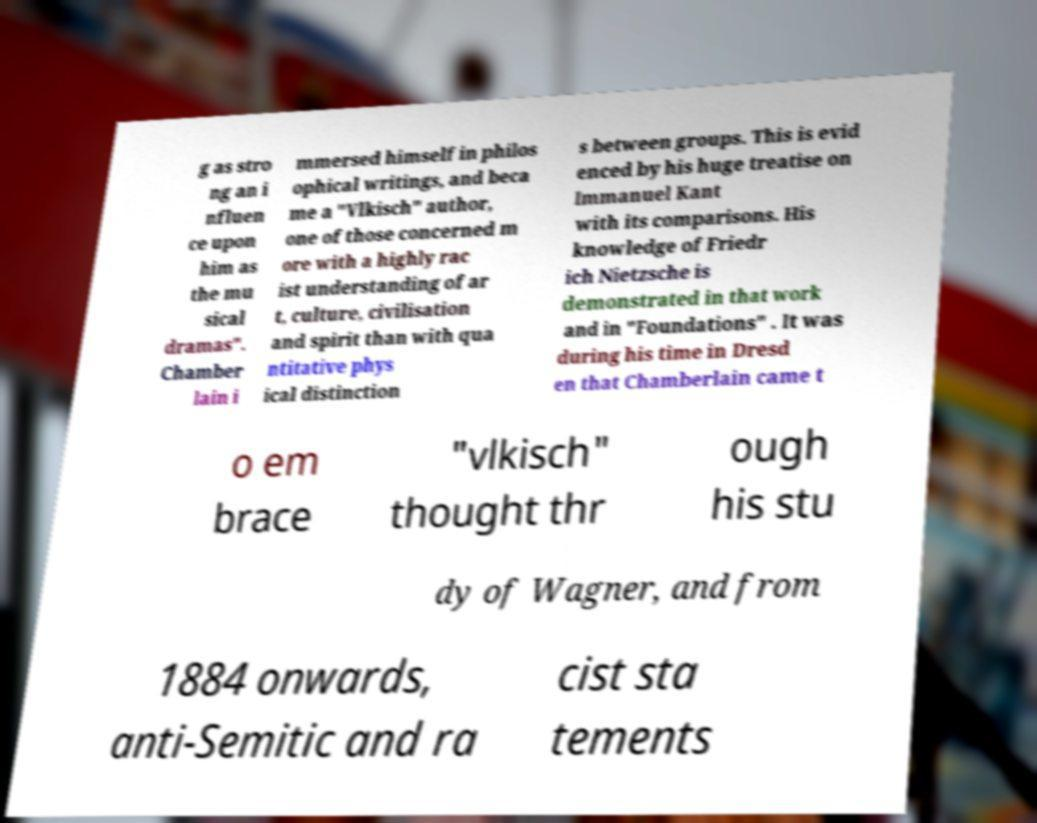There's text embedded in this image that I need extracted. Can you transcribe it verbatim? g as stro ng an i nfluen ce upon him as the mu sical dramas". Chamber lain i mmersed himself in philos ophical writings, and beca me a "Vlkisch" author, one of those concerned m ore with a highly rac ist understanding of ar t, culture, civilisation and spirit than with qua ntitative phys ical distinction s between groups. This is evid enced by his huge treatise on Immanuel Kant with its comparisons. His knowledge of Friedr ich Nietzsche is demonstrated in that work and in "Foundations" . It was during his time in Dresd en that Chamberlain came t o em brace "vlkisch" thought thr ough his stu dy of Wagner, and from 1884 onwards, anti-Semitic and ra cist sta tements 